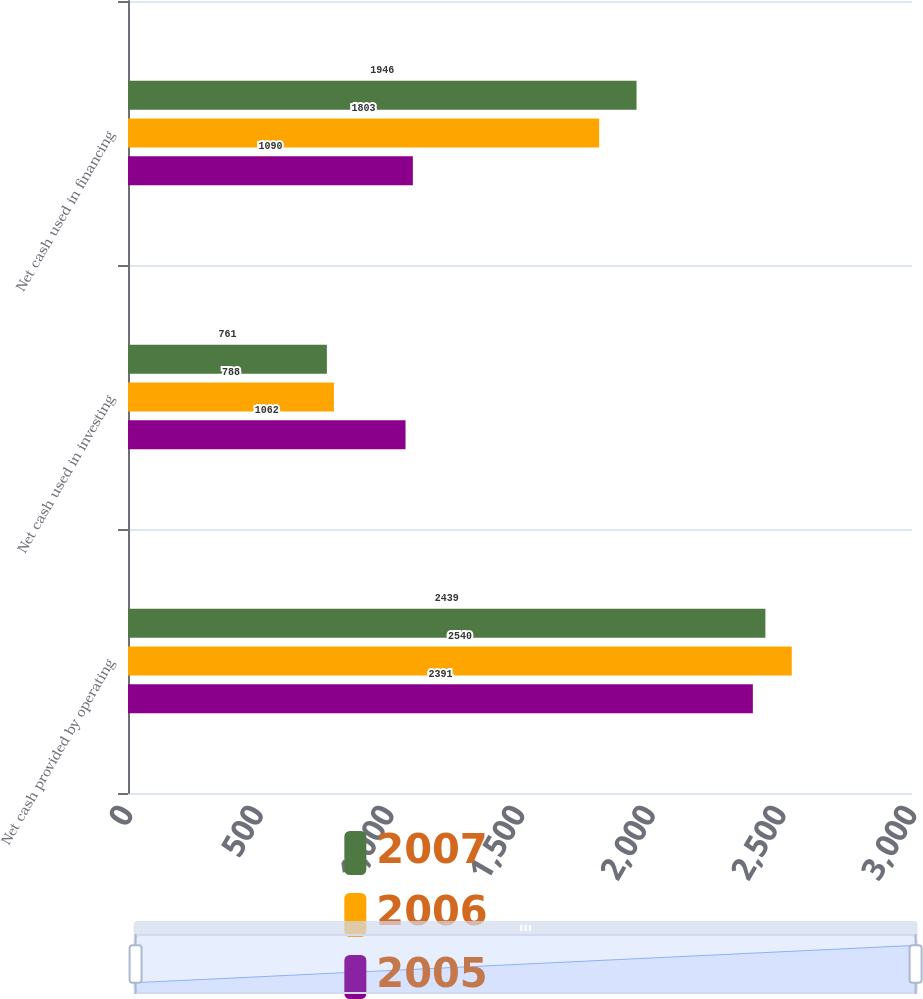<chart> <loc_0><loc_0><loc_500><loc_500><stacked_bar_chart><ecel><fcel>Net cash provided by operating<fcel>Net cash used in investing<fcel>Net cash used in financing<nl><fcel>2007<fcel>2439<fcel>761<fcel>1946<nl><fcel>2006<fcel>2540<fcel>788<fcel>1803<nl><fcel>2005<fcel>2391<fcel>1062<fcel>1090<nl></chart> 